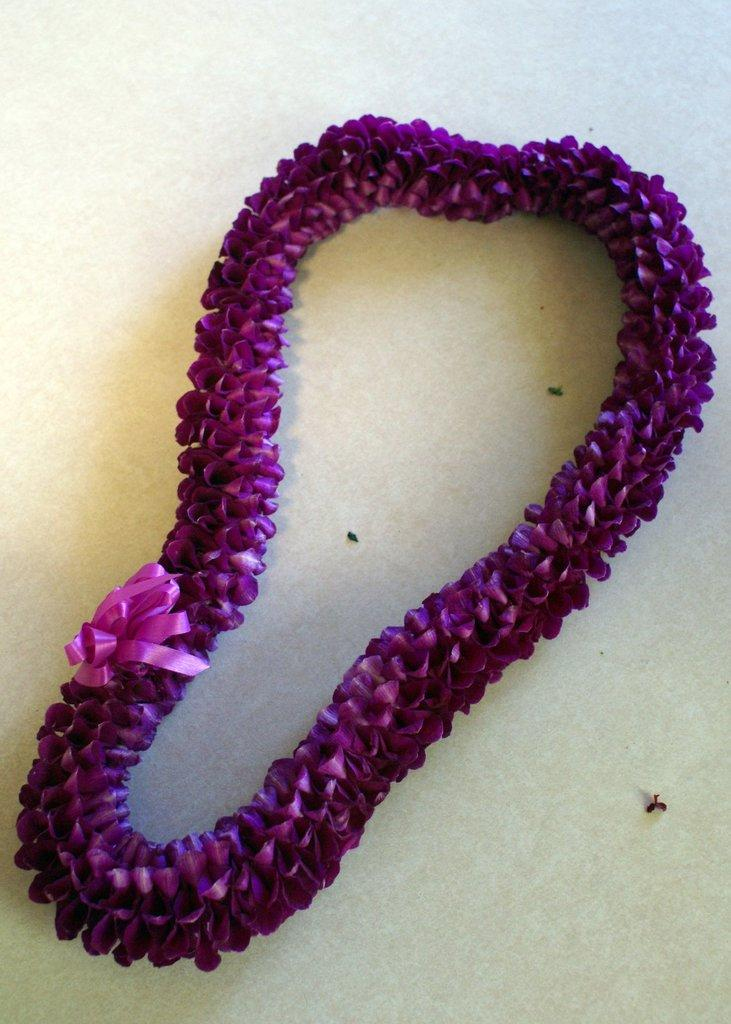What is present on the table in the image? There is a garland on the table in the image. Can you describe the location of the garland in the image? The garland is on a table in the image. What type of chair is visible in the image? There is no chair present in the image. What is the size of the garland in the image? The size of the garland cannot be determined from the image alone, as there is no reference for scale. 